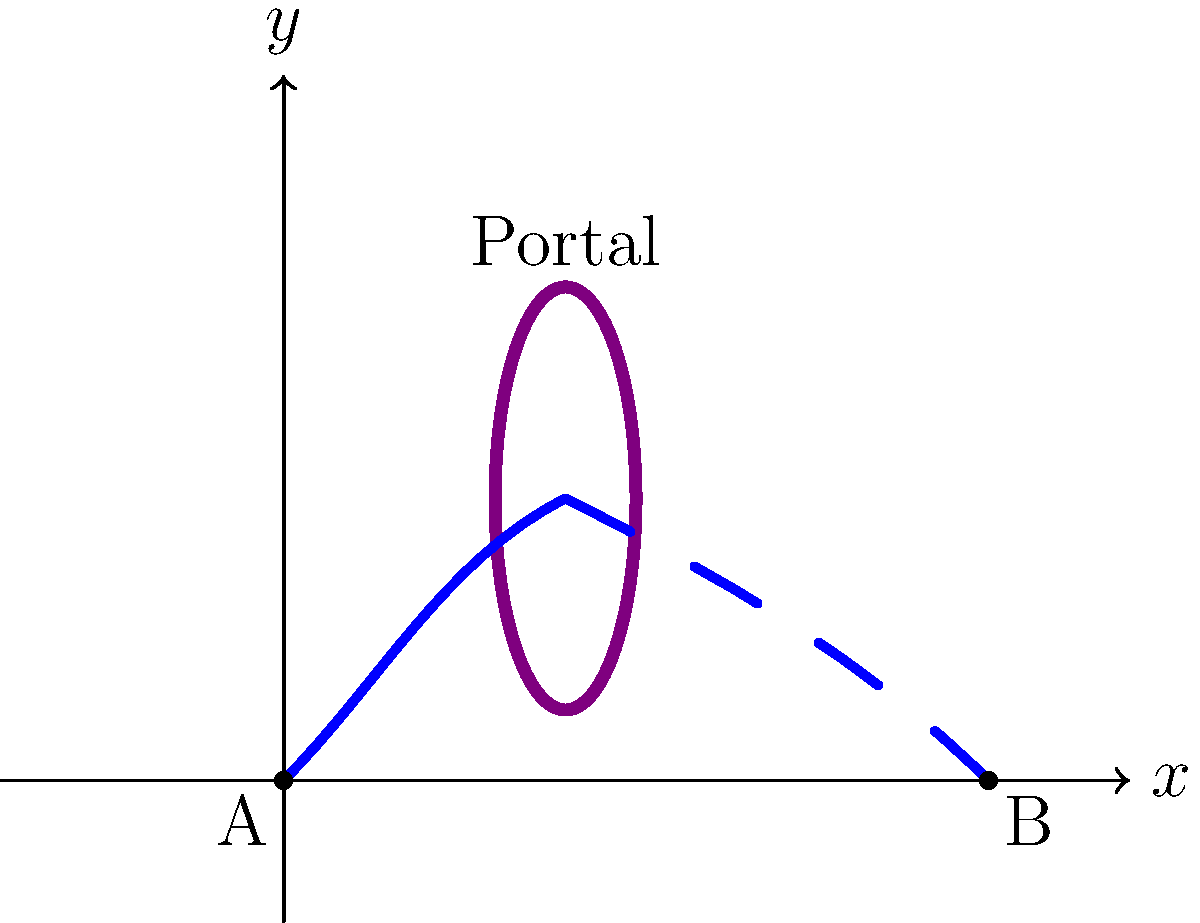In a magical realm, a creature flies from point A to point B through a mystical portal. The creature's trajectory before entering the portal follows the equation $y = x - \frac{1}{4}x^2$, and after exiting the portal, it follows $y = 5 - \frac{1}{4}(x-2)^2$. If the portal is centered at (2, 2), what is the total distance traveled by the creature from A to B? To solve this problem, we'll follow these steps:

1) First, we need to find the arc length of the curve before the portal. The formula for arc length is:

   $L = \int_{a}^{b} \sqrt{1 + (\frac{dy}{dx})^2} dx$

2) For the first part of the trajectory:
   $y = x - \frac{1}{4}x^2$
   $\frac{dy}{dx} = 1 - \frac{1}{2}x$

3) Substituting into the arc length formula:
   $L_1 = \int_{0}^{2} \sqrt{1 + (1 - \frac{1}{2}x)^2} dx$

4) For the second part of the trajectory:
   $y = 5 - \frac{1}{4}(x-2)^2$
   $\frac{dy}{dx} = -\frac{1}{2}(x-2)$

5) The arc length for the second part:
   $L_2 = \int_{2}^{5} \sqrt{1 + (-\frac{1}{2}(x-2))^2} dx$

6) The total distance is the sum of these two integrals:
   $L_{total} = L_1 + L_2$

7) These integrals are complex and typically solved numerically. Using a numerical integration method, we get:
   $L_1 \approx 2.15$
   $L_2 \approx 3.20$

8) Therefore, the total distance is approximately:
   $L_{total} \approx 2.15 + 3.20 = 5.35$ units
Answer: 5.35 units 